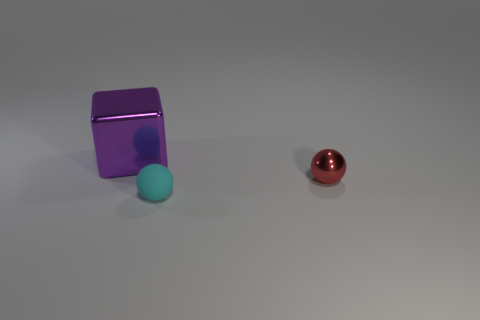Add 3 large metallic things. How many objects exist? 6 Subtract all spheres. How many objects are left? 1 Subtract all rubber spheres. Subtract all red spheres. How many objects are left? 1 Add 3 purple objects. How many purple objects are left? 4 Add 1 cylinders. How many cylinders exist? 1 Subtract 0 cyan cubes. How many objects are left? 3 